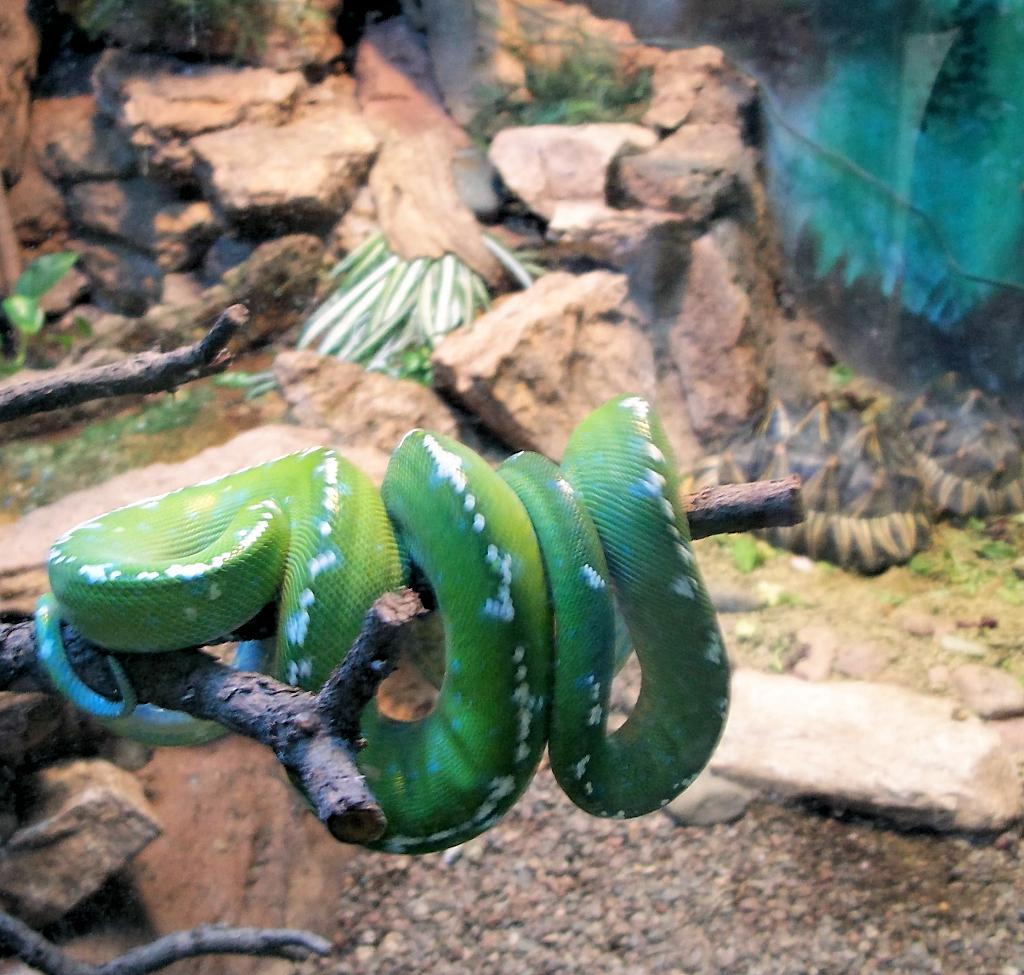What animal is on the branch in the image? There is a snake on a branch in the image. What can be seen in the background of the image? There are rocks and plants in the background of the image. What type of seed can be seen growing on the snake's head in the image? There is no seed growing on the snake's head in the image; it is just a snake on a branch. 